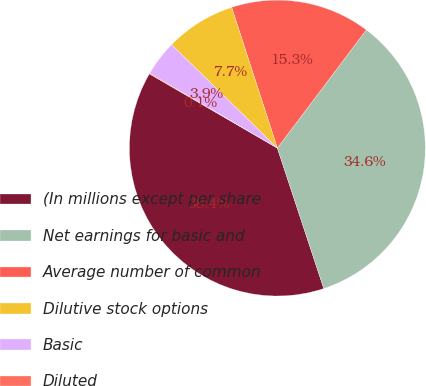Convert chart to OTSL. <chart><loc_0><loc_0><loc_500><loc_500><pie_chart><fcel>(In millions except per share<fcel>Net earnings for basic and<fcel>Average number of common<fcel>Dilutive stock options<fcel>Basic<fcel>Diluted<nl><fcel>38.45%<fcel>34.65%<fcel>15.27%<fcel>7.68%<fcel>3.88%<fcel>0.08%<nl></chart> 